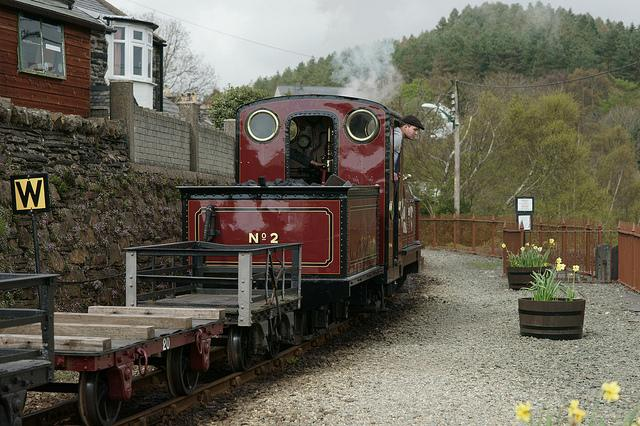Why are those flowers growing in those bins? Please explain your reasoning. gardener. The containers appear to be methodically placed and would be professional manicured. someone responsible for flower growth would be answer a. 